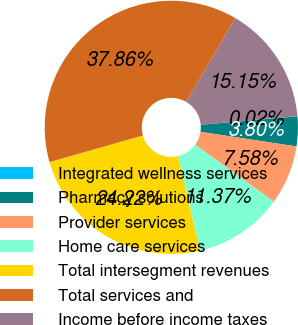<chart> <loc_0><loc_0><loc_500><loc_500><pie_chart><fcel>Integrated wellness services<fcel>Pharmacy solutions<fcel>Provider services<fcel>Home care services<fcel>Total intersegment revenues<fcel>Total services and<fcel>Income before income taxes<nl><fcel>0.02%<fcel>3.8%<fcel>7.58%<fcel>11.37%<fcel>24.22%<fcel>37.86%<fcel>15.15%<nl></chart> 